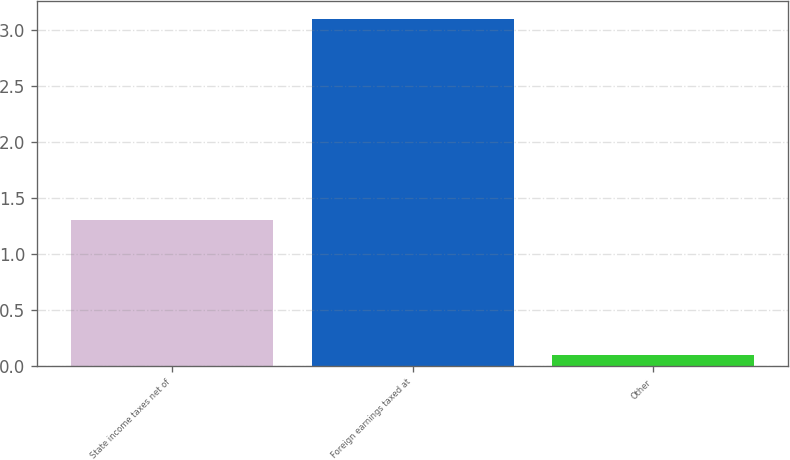Convert chart to OTSL. <chart><loc_0><loc_0><loc_500><loc_500><bar_chart><fcel>State income taxes net of<fcel>Foreign earnings taxed at<fcel>Other<nl><fcel>1.3<fcel>3.1<fcel>0.1<nl></chart> 